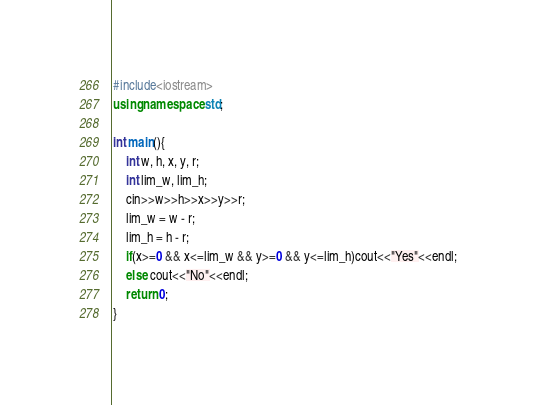<code> <loc_0><loc_0><loc_500><loc_500><_C++_>#include<iostream>
using namespace std;

int main(){
    int w, h, x, y, r;
    int lim_w, lim_h;
    cin>>w>>h>>x>>y>>r;
    lim_w = w - r;
    lim_h = h - r;
    if(x>=0 && x<=lim_w && y>=0 && y<=lim_h)cout<<"Yes"<<endl;
    else cout<<"No"<<endl;
    return 0;
}
</code> 